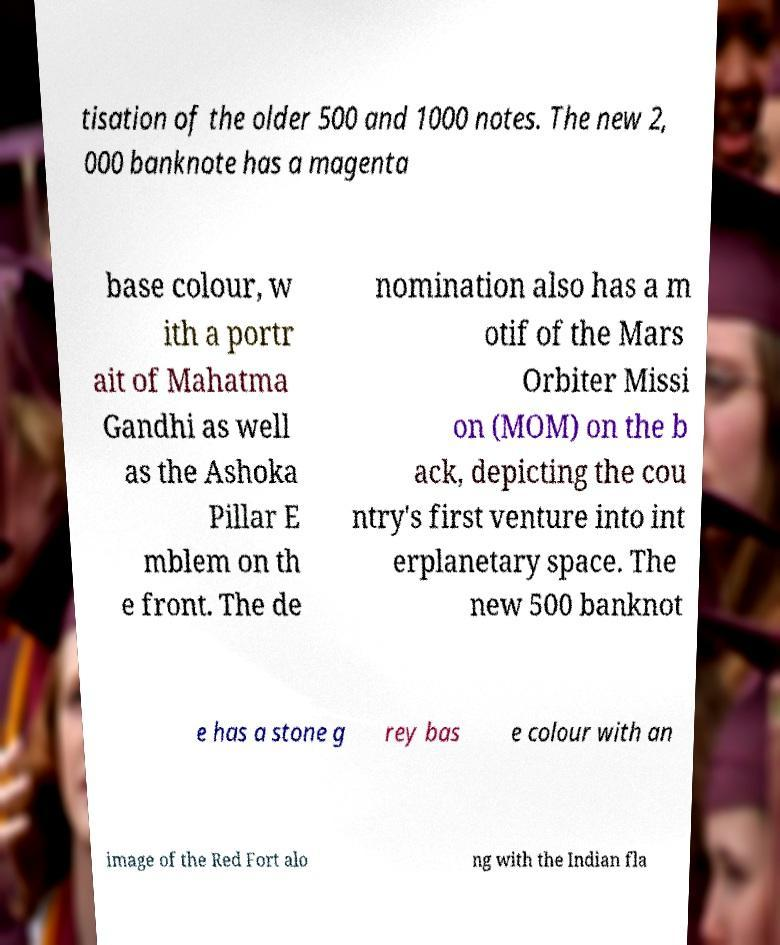I need the written content from this picture converted into text. Can you do that? tisation of the older 500 and 1000 notes. The new 2, 000 banknote has a magenta base colour, w ith a portr ait of Mahatma Gandhi as well as the Ashoka Pillar E mblem on th e front. The de nomination also has a m otif of the Mars Orbiter Missi on (MOM) on the b ack, depicting the cou ntry's first venture into int erplanetary space. The new 500 banknot e has a stone g rey bas e colour with an image of the Red Fort alo ng with the Indian fla 